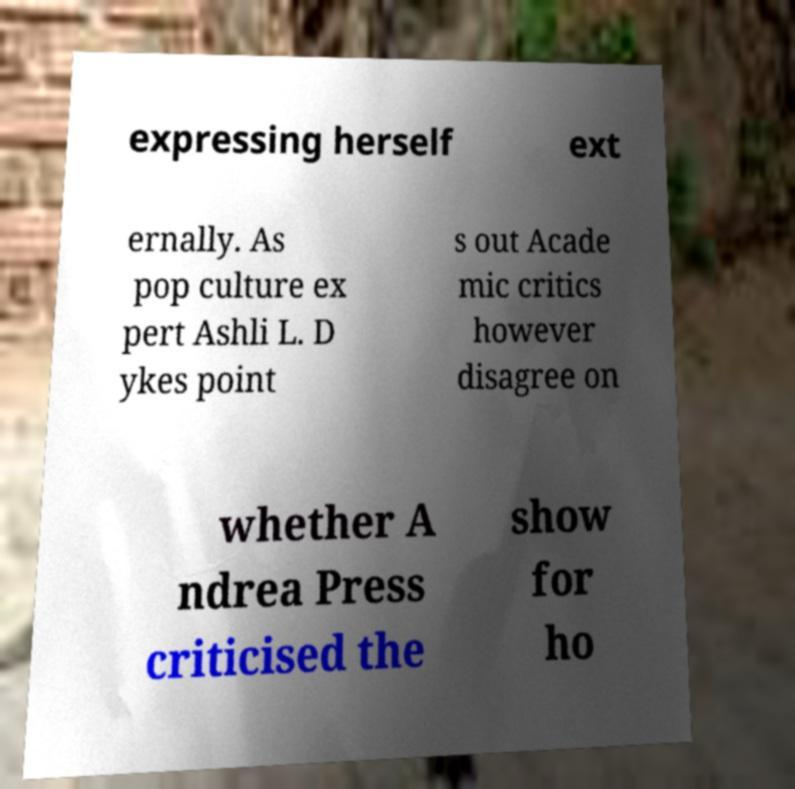Can you accurately transcribe the text from the provided image for me? expressing herself ext ernally. As pop culture ex pert Ashli L. D ykes point s out Acade mic critics however disagree on whether A ndrea Press criticised the show for ho 